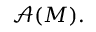<formula> <loc_0><loc_0><loc_500><loc_500>{ \mathcal { A } } ( M ) .</formula> 